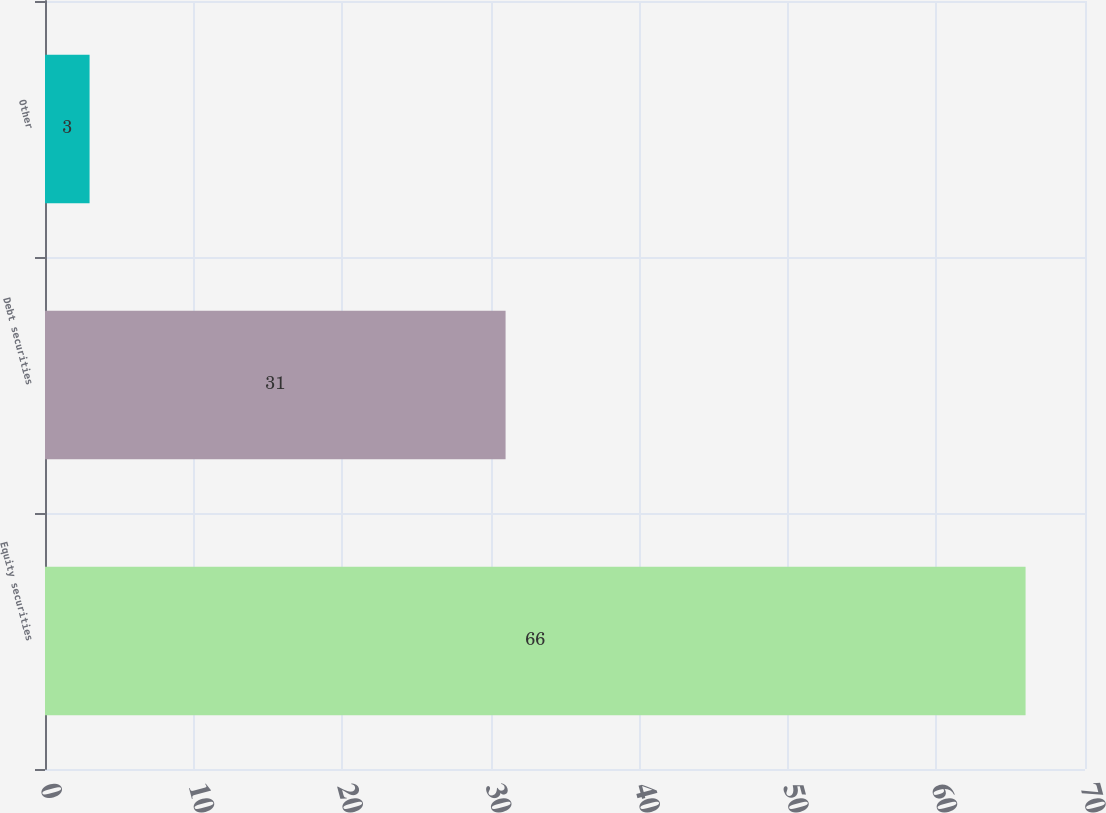Convert chart. <chart><loc_0><loc_0><loc_500><loc_500><bar_chart><fcel>Equity securities<fcel>Debt securities<fcel>Other<nl><fcel>66<fcel>31<fcel>3<nl></chart> 